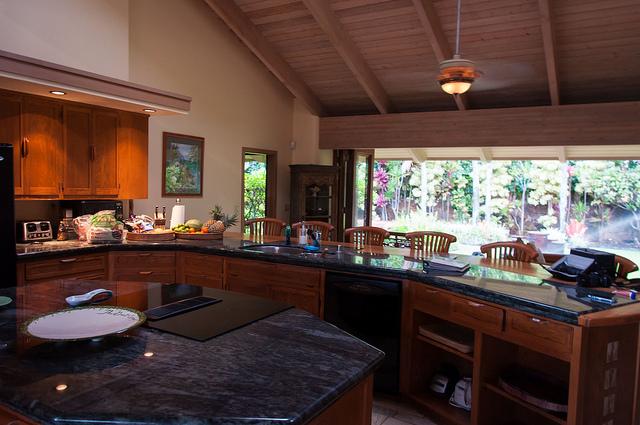What number of pictures are on the walls?
Concise answer only. 1. Is this a bar?
Be succinct. No. What room is this?
Quick response, please. Kitchen. How many stools are under the table?
Answer briefly. 6. What is the brightest thing in the room?
Answer briefly. Light. Are the chairs wooden?
Be succinct. Yes. What room is being shown?
Short answer required. Kitchen. How many windows are there?
Give a very brief answer. 1. Would one call this style of furnishing a bit minimal?
Short answer required. No. How many lamps are turned off?
Quick response, please. 0. Was this picture taken during the summer?
Quick response, please. Yes. How many pictures are hanging?
Answer briefly. 1. Can more than three people eat together here?
Write a very short answer. Yes. 